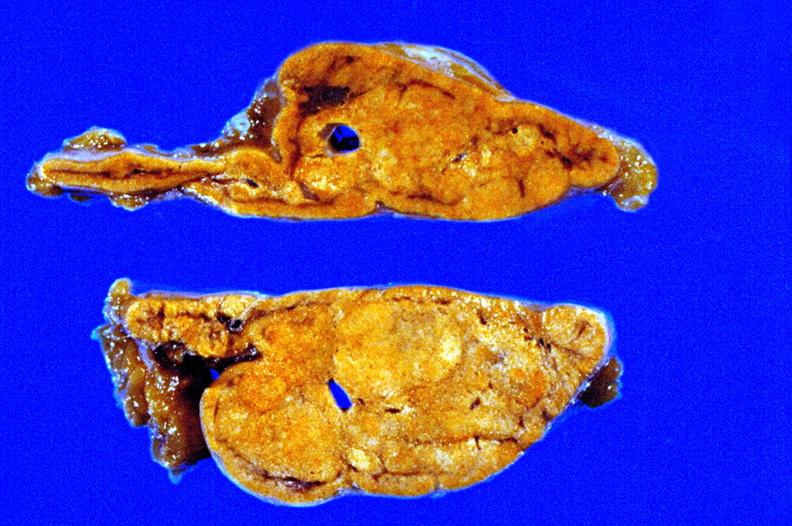what is fixed tissue cut?
Answer the question using a single word or phrase. Surface close-up view rather good apparently non-functional 